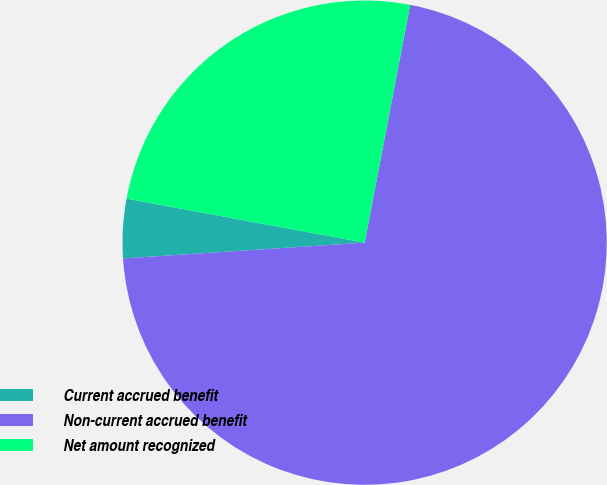<chart> <loc_0><loc_0><loc_500><loc_500><pie_chart><fcel>Current accrued benefit<fcel>Non-current accrued benefit<fcel>Net amount recognized<nl><fcel>3.95%<fcel>70.95%<fcel>25.1%<nl></chart> 